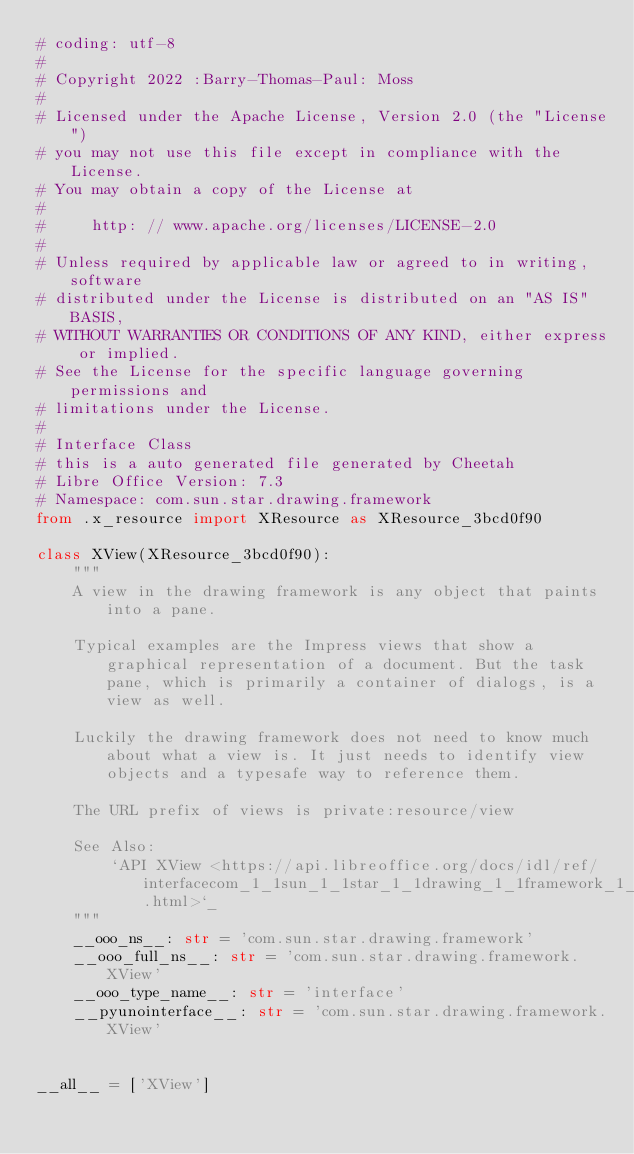<code> <loc_0><loc_0><loc_500><loc_500><_Python_># coding: utf-8
#
# Copyright 2022 :Barry-Thomas-Paul: Moss
#
# Licensed under the Apache License, Version 2.0 (the "License")
# you may not use this file except in compliance with the License.
# You may obtain a copy of the License at
#
#     http: // www.apache.org/licenses/LICENSE-2.0
#
# Unless required by applicable law or agreed to in writing, software
# distributed under the License is distributed on an "AS IS" BASIS,
# WITHOUT WARRANTIES OR CONDITIONS OF ANY KIND, either express or implied.
# See the License for the specific language governing permissions and
# limitations under the License.
#
# Interface Class
# this is a auto generated file generated by Cheetah
# Libre Office Version: 7.3
# Namespace: com.sun.star.drawing.framework
from .x_resource import XResource as XResource_3bcd0f90

class XView(XResource_3bcd0f90):
    """
    A view in the drawing framework is any object that paints into a pane.
    
    Typical examples are the Impress views that show a graphical representation of a document. But the task pane, which is primarily a container of dialogs, is a view as well.
    
    Luckily the drawing framework does not need to know much about what a view is. It just needs to identify view objects and a typesafe way to reference them.
    
    The URL prefix of views is private:resource/view

    See Also:
        `API XView <https://api.libreoffice.org/docs/idl/ref/interfacecom_1_1sun_1_1star_1_1drawing_1_1framework_1_1XView.html>`_
    """
    __ooo_ns__: str = 'com.sun.star.drawing.framework'
    __ooo_full_ns__: str = 'com.sun.star.drawing.framework.XView'
    __ooo_type_name__: str = 'interface'
    __pyunointerface__: str = 'com.sun.star.drawing.framework.XView'


__all__ = ['XView']

</code> 